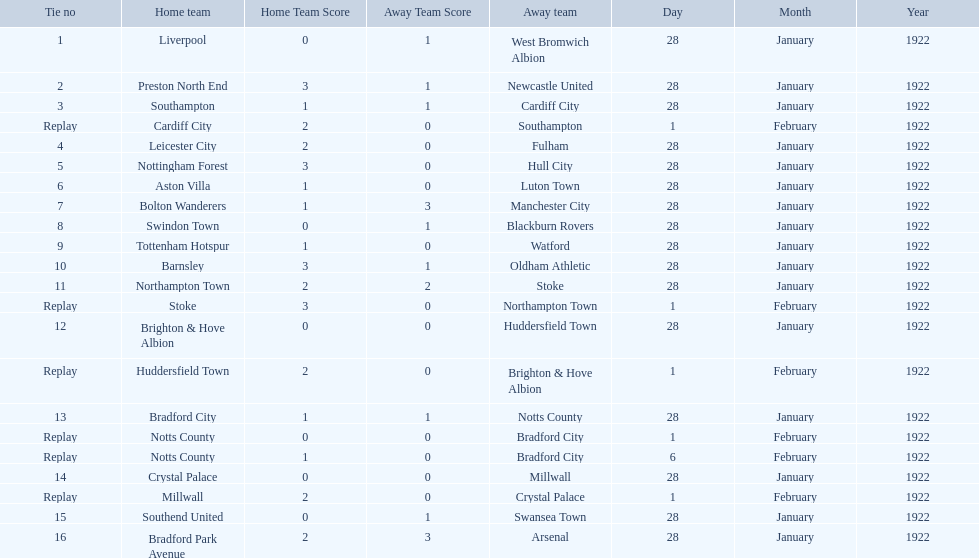What was the score in the aston villa game? 1–0. Which other team had an identical score? Tottenham Hotspur. 